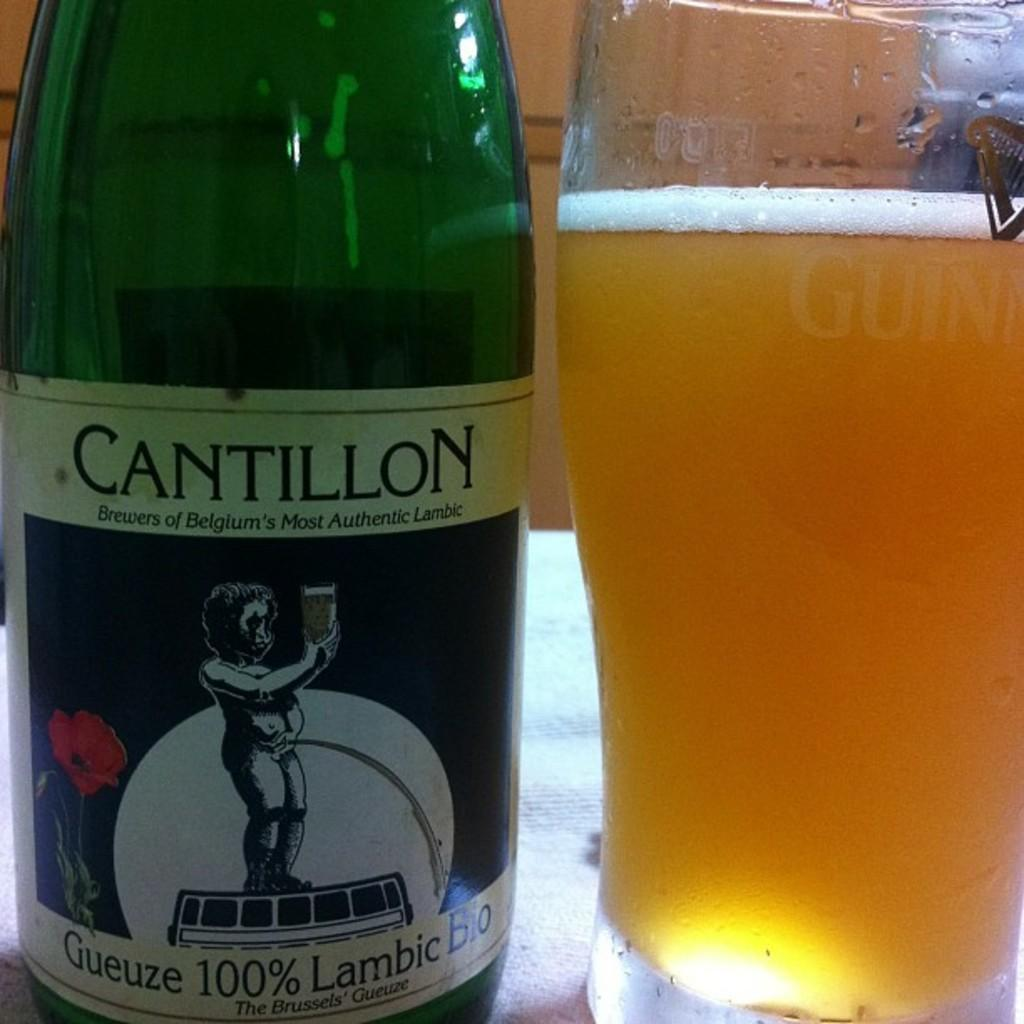<image>
Provide a brief description of the given image. Green bottle with a label that says Cantillon on it. 